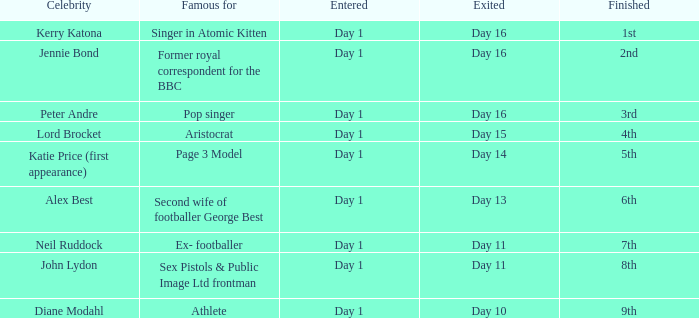Name the finished for kerry katona 1.0. 